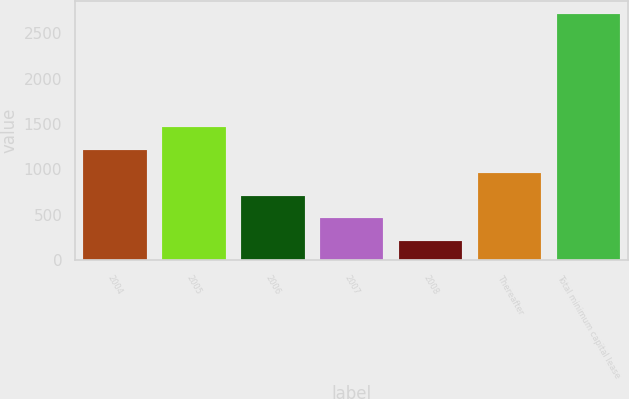Convert chart. <chart><loc_0><loc_0><loc_500><loc_500><bar_chart><fcel>2004<fcel>2005<fcel>2006<fcel>2007<fcel>2008<fcel>Thereafter<fcel>Total minimum capital lease<nl><fcel>1210.4<fcel>1461.5<fcel>708.2<fcel>457.1<fcel>206<fcel>959.3<fcel>2717<nl></chart> 